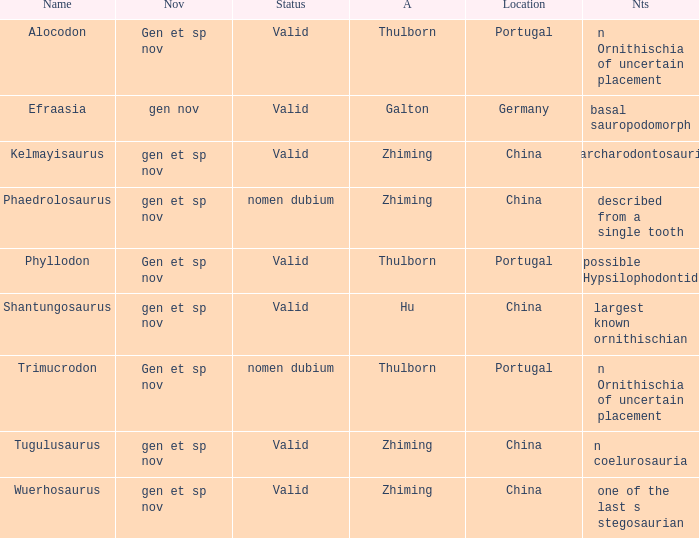What is the Name of the dinosaur, whose notes are, "n ornithischia of uncertain placement"? Alocodon, Trimucrodon. 